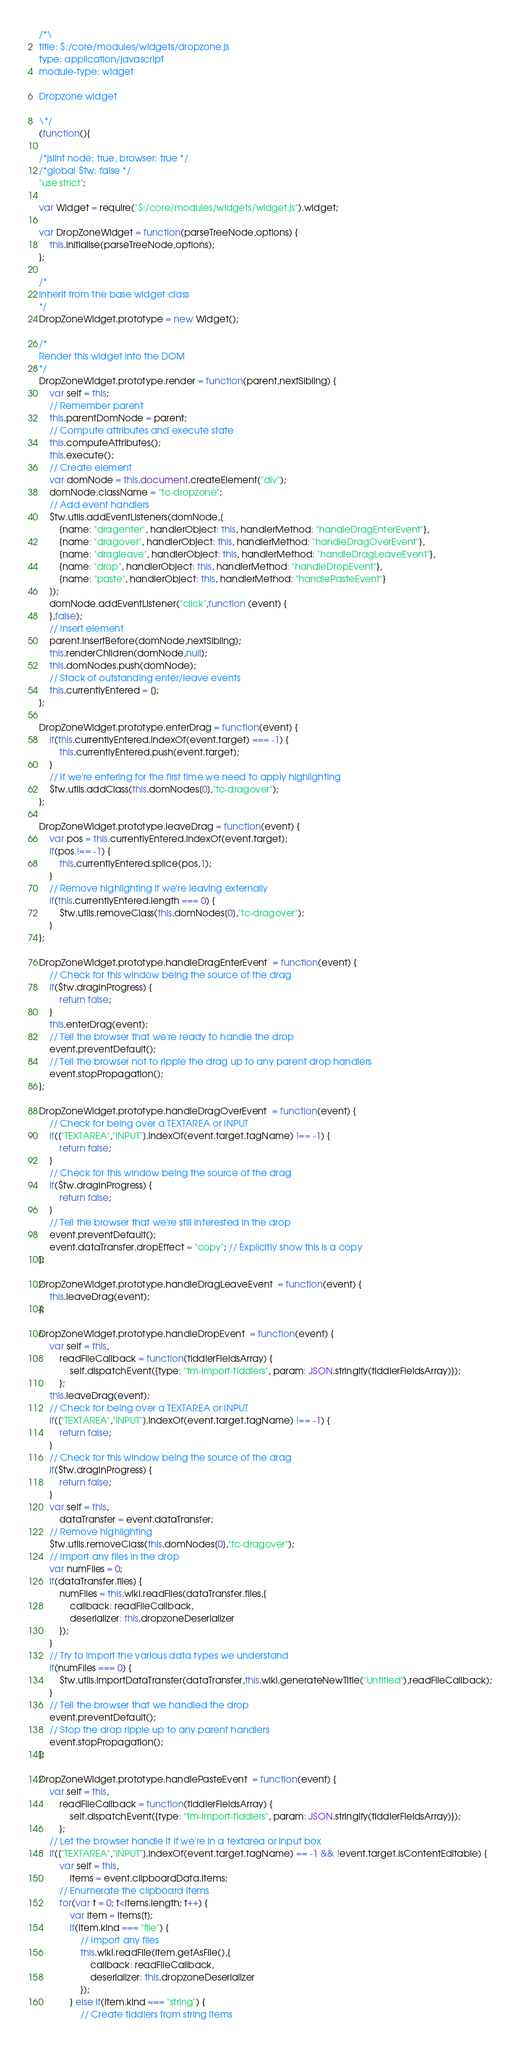<code> <loc_0><loc_0><loc_500><loc_500><_JavaScript_>/*\
title: $:/core/modules/widgets/dropzone.js
type: application/javascript
module-type: widget

Dropzone widget

\*/
(function(){

/*jslint node: true, browser: true */
/*global $tw: false */
"use strict";

var Widget = require("$:/core/modules/widgets/widget.js").widget;

var DropZoneWidget = function(parseTreeNode,options) {
	this.initialise(parseTreeNode,options);
};

/*
Inherit from the base widget class
*/
DropZoneWidget.prototype = new Widget();

/*
Render this widget into the DOM
*/
DropZoneWidget.prototype.render = function(parent,nextSibling) {
	var self = this;
	// Remember parent
	this.parentDomNode = parent;
	// Compute attributes and execute state
	this.computeAttributes();
	this.execute();
	// Create element
	var domNode = this.document.createElement("div");
	domNode.className = "tc-dropzone";
	// Add event handlers
	$tw.utils.addEventListeners(domNode,[
		{name: "dragenter", handlerObject: this, handlerMethod: "handleDragEnterEvent"},
		{name: "dragover", handlerObject: this, handlerMethod: "handleDragOverEvent"},
		{name: "dragleave", handlerObject: this, handlerMethod: "handleDragLeaveEvent"},
		{name: "drop", handlerObject: this, handlerMethod: "handleDropEvent"},
		{name: "paste", handlerObject: this, handlerMethod: "handlePasteEvent"}
	]);
	domNode.addEventListener("click",function (event) {
	},false);
	// Insert element
	parent.insertBefore(domNode,nextSibling);
	this.renderChildren(domNode,null);
	this.domNodes.push(domNode);
	// Stack of outstanding enter/leave events
	this.currentlyEntered = [];
};

DropZoneWidget.prototype.enterDrag = function(event) {
	if(this.currentlyEntered.indexOf(event.target) === -1) {
		this.currentlyEntered.push(event.target);
	}
	// If we're entering for the first time we need to apply highlighting
	$tw.utils.addClass(this.domNodes[0],"tc-dragover");
};

DropZoneWidget.prototype.leaveDrag = function(event) {
	var pos = this.currentlyEntered.indexOf(event.target);
	if(pos !== -1) {
		this.currentlyEntered.splice(pos,1);
	}
	// Remove highlighting if we're leaving externally
	if(this.currentlyEntered.length === 0) {
		$tw.utils.removeClass(this.domNodes[0],"tc-dragover");
	}
};

DropZoneWidget.prototype.handleDragEnterEvent  = function(event) {
	// Check for this window being the source of the drag
	if($tw.dragInProgress) {
		return false;
	}
	this.enterDrag(event);
	// Tell the browser that we're ready to handle the drop
	event.preventDefault();
	// Tell the browser not to ripple the drag up to any parent drop handlers
	event.stopPropagation();
};

DropZoneWidget.prototype.handleDragOverEvent  = function(event) {
	// Check for being over a TEXTAREA or INPUT
	if(["TEXTAREA","INPUT"].indexOf(event.target.tagName) !== -1) {
		return false;
	}
	// Check for this window being the source of the drag
	if($tw.dragInProgress) {
		return false;
	}
	// Tell the browser that we're still interested in the drop
	event.preventDefault();
	event.dataTransfer.dropEffect = "copy"; // Explicitly show this is a copy
};

DropZoneWidget.prototype.handleDragLeaveEvent  = function(event) {
	this.leaveDrag(event);
};

DropZoneWidget.prototype.handleDropEvent  = function(event) {
	var self = this,
		readFileCallback = function(tiddlerFieldsArray) {
			self.dispatchEvent({type: "tm-import-tiddlers", param: JSON.stringify(tiddlerFieldsArray)});
		};
	this.leaveDrag(event);
	// Check for being over a TEXTAREA or INPUT
	if(["TEXTAREA","INPUT"].indexOf(event.target.tagName) !== -1) {
		return false;
	}
	// Check for this window being the source of the drag
	if($tw.dragInProgress) {
		return false;
	}
	var self = this,
		dataTransfer = event.dataTransfer;
	// Remove highlighting
	$tw.utils.removeClass(this.domNodes[0],"tc-dragover");
	// Import any files in the drop
	var numFiles = 0;
	if(dataTransfer.files) {
		numFiles = this.wiki.readFiles(dataTransfer.files,{
			callback: readFileCallback,
			deserializer: this.dropzoneDeserializer
		});
	}
	// Try to import the various data types we understand
	if(numFiles === 0) {
		$tw.utils.importDataTransfer(dataTransfer,this.wiki.generateNewTitle("Untitled"),readFileCallback);
	}
	// Tell the browser that we handled the drop
	event.preventDefault();
	// Stop the drop ripple up to any parent handlers
	event.stopPropagation();
};

DropZoneWidget.prototype.handlePasteEvent  = function(event) {
	var self = this,
		readFileCallback = function(tiddlerFieldsArray) {
			self.dispatchEvent({type: "tm-import-tiddlers", param: JSON.stringify(tiddlerFieldsArray)});
		};
	// Let the browser handle it if we're in a textarea or input box
	if(["TEXTAREA","INPUT"].indexOf(event.target.tagName) == -1 && !event.target.isContentEditable) {
		var self = this,
			items = event.clipboardData.items;
		// Enumerate the clipboard items
		for(var t = 0; t<items.length; t++) {
			var item = items[t];
			if(item.kind === "file") {
				// Import any files
				this.wiki.readFile(item.getAsFile(),{
					callback: readFileCallback,
					deserializer: this.dropzoneDeserializer
				});
			} else if(item.kind === "string") {
				// Create tiddlers from string items</code> 